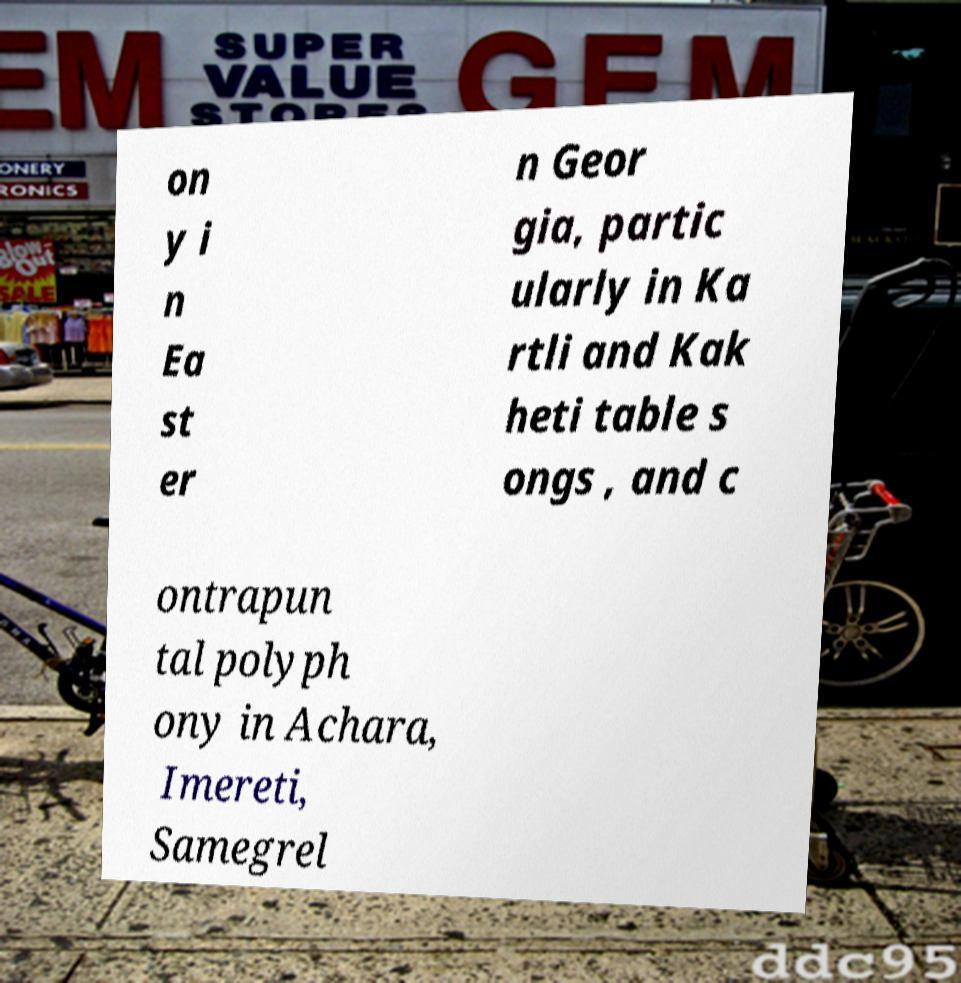Can you read and provide the text displayed in the image?This photo seems to have some interesting text. Can you extract and type it out for me? on y i n Ea st er n Geor gia, partic ularly in Ka rtli and Kak heti table s ongs , and c ontrapun tal polyph ony in Achara, Imereti, Samegrel 